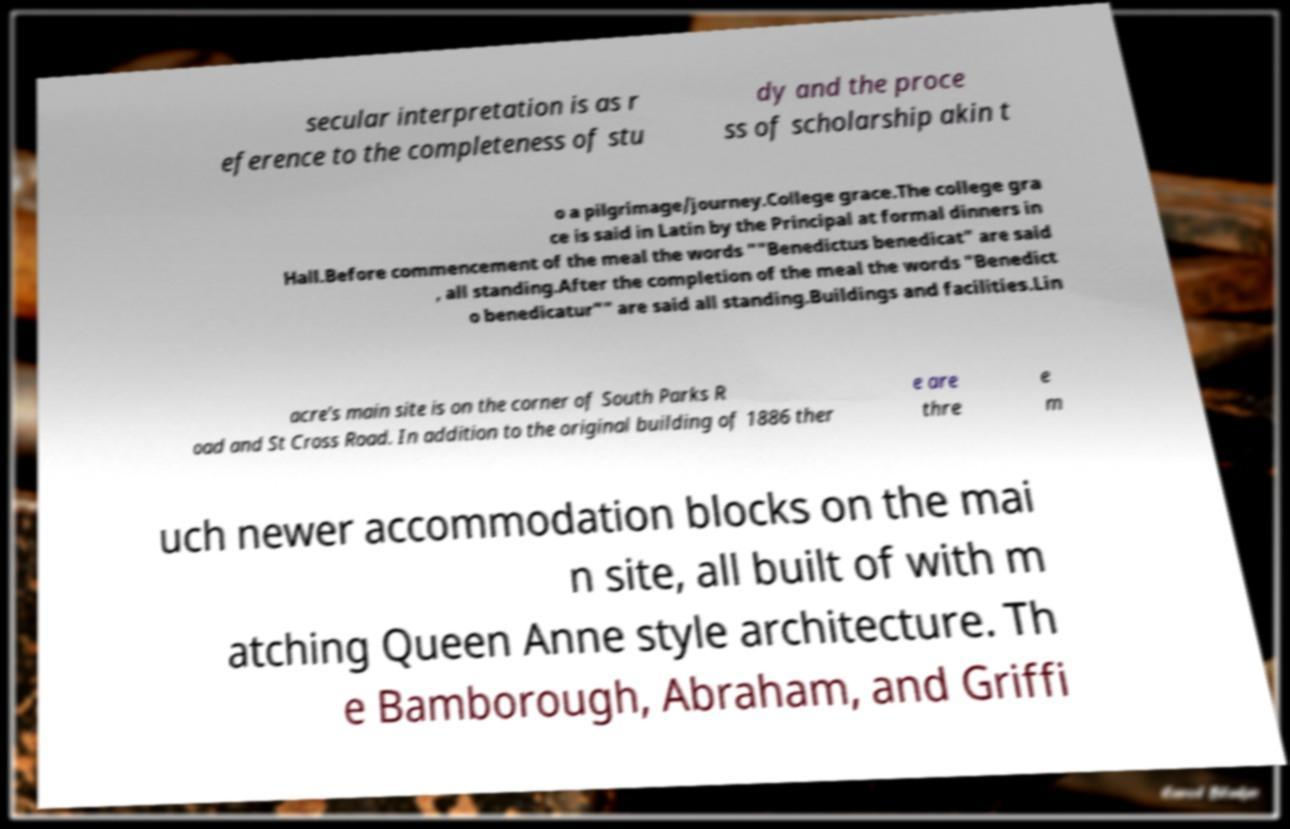Can you read and provide the text displayed in the image?This photo seems to have some interesting text. Can you extract and type it out for me? secular interpretation is as r eference to the completeness of stu dy and the proce ss of scholarship akin t o a pilgrimage/journey.College grace.The college gra ce is said in Latin by the Principal at formal dinners in Hall.Before commencement of the meal the words ""Benedictus benedicat" are said , all standing.After the completion of the meal the words "Benedict o benedicatur"" are said all standing.Buildings and facilities.Lin acre's main site is on the corner of South Parks R oad and St Cross Road. In addition to the original building of 1886 ther e are thre e m uch newer accommodation blocks on the mai n site, all built of with m atching Queen Anne style architecture. Th e Bamborough, Abraham, and Griffi 